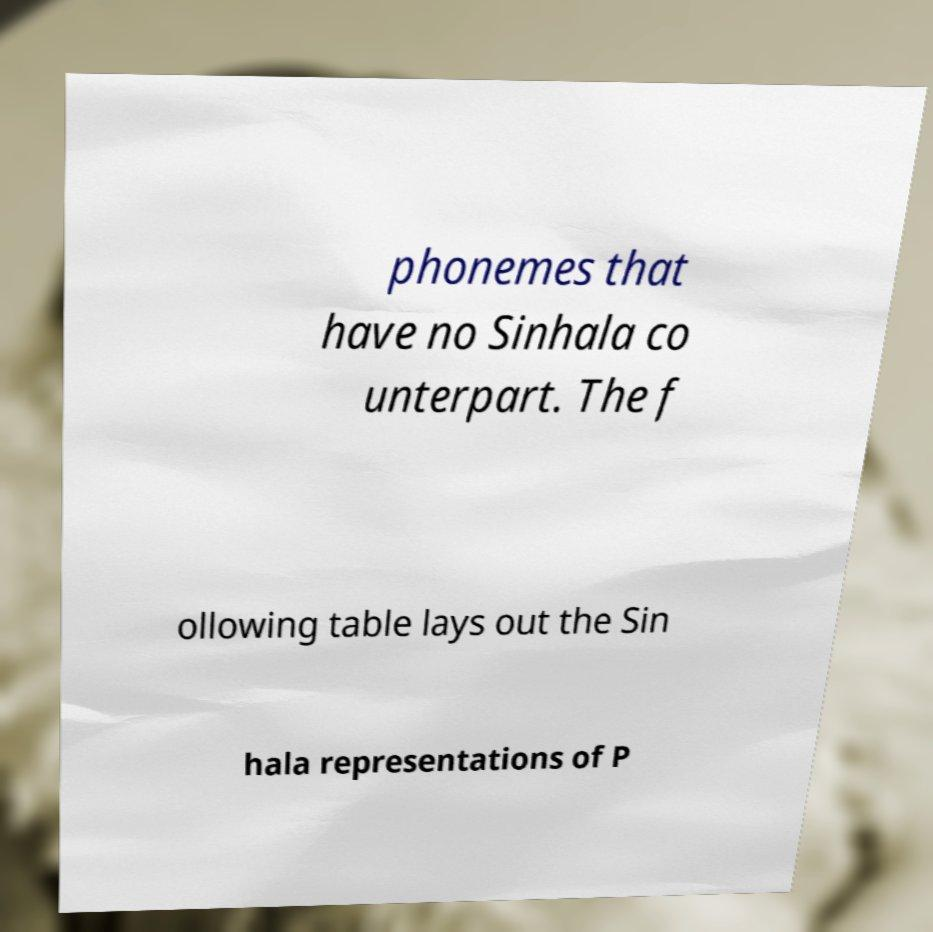Can you read and provide the text displayed in the image?This photo seems to have some interesting text. Can you extract and type it out for me? phonemes that have no Sinhala co unterpart. The f ollowing table lays out the Sin hala representations of P 